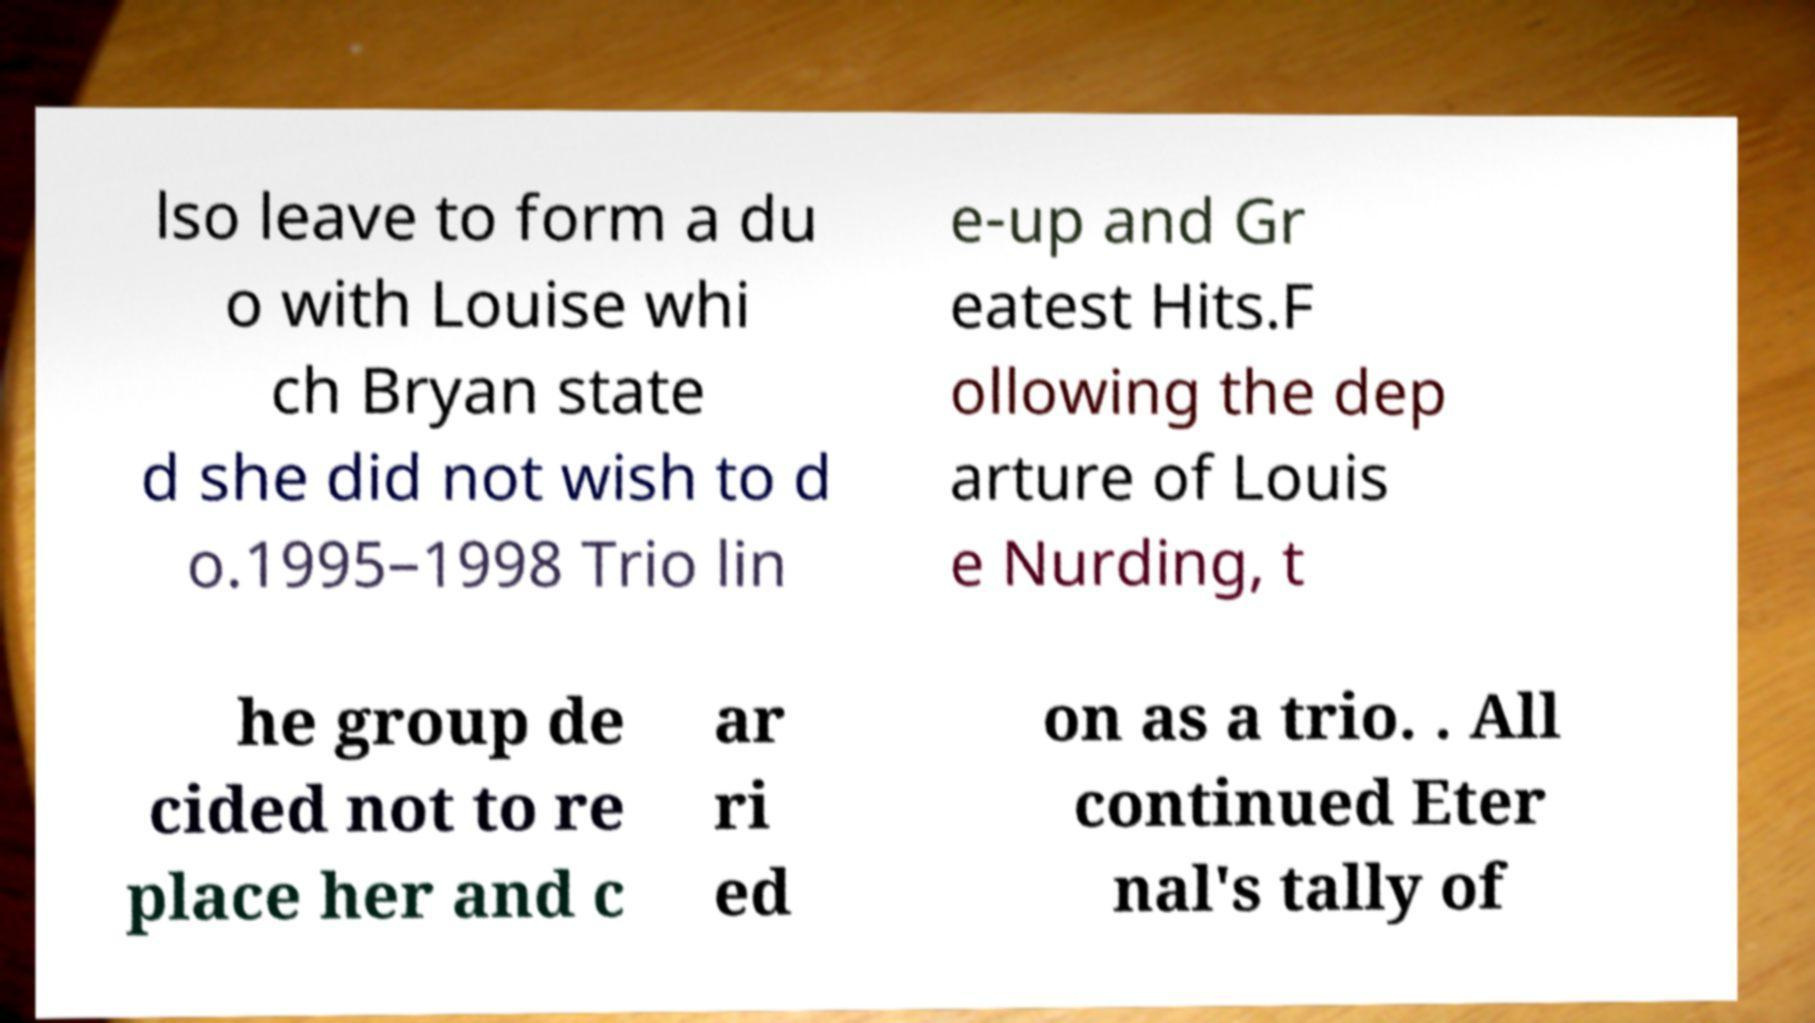Could you extract and type out the text from this image? lso leave to form a du o with Louise whi ch Bryan state d she did not wish to d o.1995–1998 Trio lin e-up and Gr eatest Hits.F ollowing the dep arture of Louis e Nurding, t he group de cided not to re place her and c ar ri ed on as a trio. . All continued Eter nal's tally of 